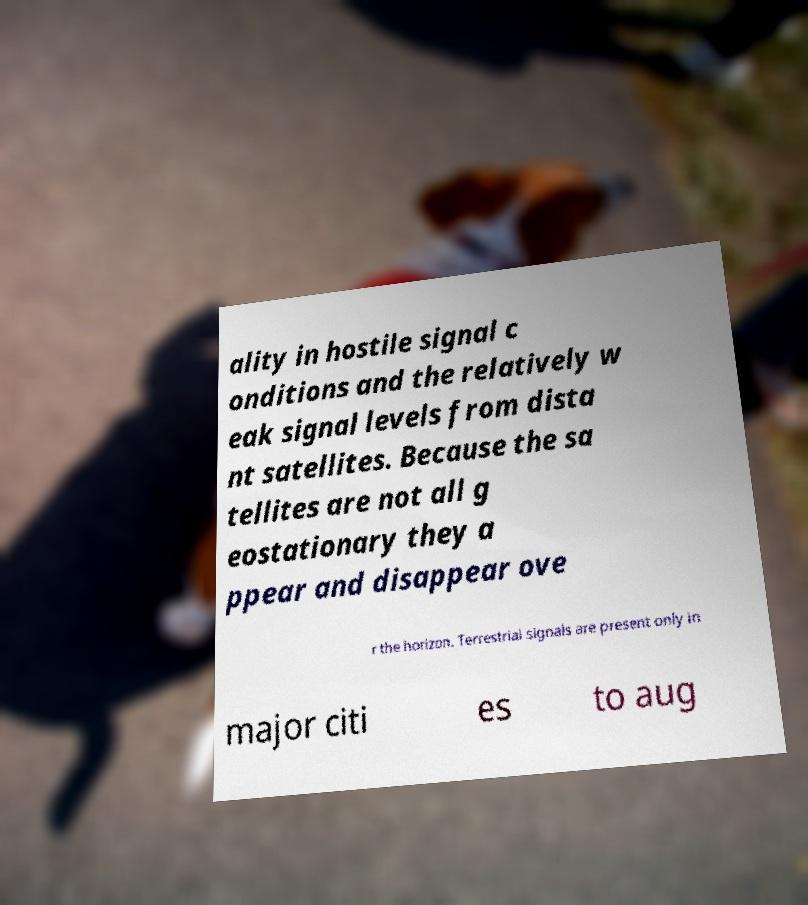Please identify and transcribe the text found in this image. ality in hostile signal c onditions and the relatively w eak signal levels from dista nt satellites. Because the sa tellites are not all g eostationary they a ppear and disappear ove r the horizon. Terrestrial signals are present only in major citi es to aug 